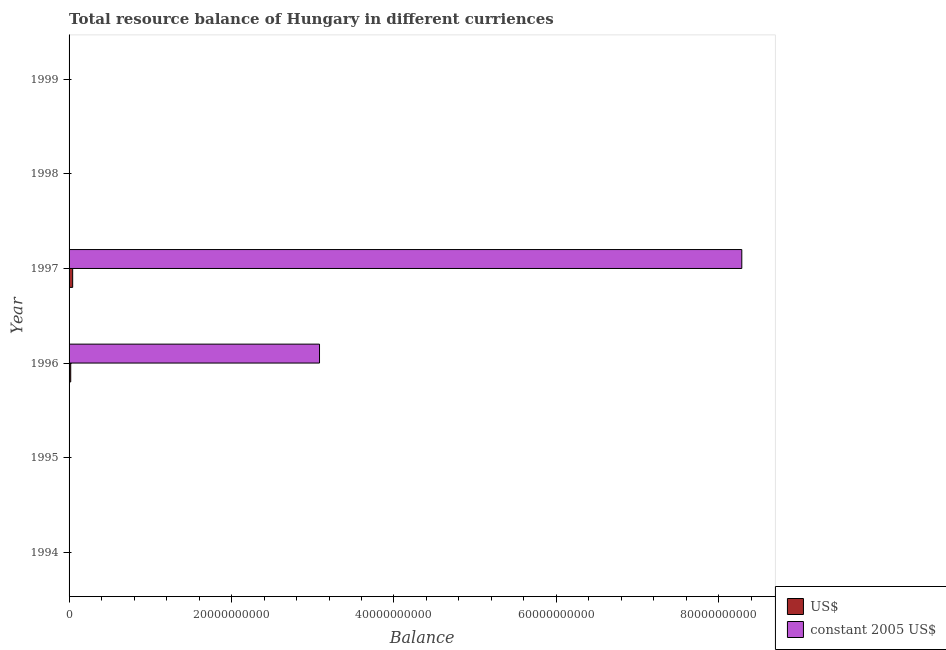How many different coloured bars are there?
Ensure brevity in your answer.  2. Are the number of bars per tick equal to the number of legend labels?
Your answer should be very brief. No. Are the number of bars on each tick of the Y-axis equal?
Make the answer very short. No. How many bars are there on the 5th tick from the top?
Give a very brief answer. 0. What is the label of the 5th group of bars from the top?
Offer a very short reply. 1995. What is the resource balance in constant us$ in 1996?
Keep it short and to the point. 3.08e+1. Across all years, what is the maximum resource balance in us$?
Keep it short and to the point. 4.43e+08. Across all years, what is the minimum resource balance in constant us$?
Offer a terse response. 0. What is the total resource balance in us$ in the graph?
Provide a short and direct response. 6.45e+08. What is the difference between the resource balance in constant us$ in 1996 and that in 1997?
Provide a succinct answer. -5.20e+1. What is the difference between the resource balance in us$ in 1999 and the resource balance in constant us$ in 1996?
Your answer should be very brief. -3.08e+1. What is the average resource balance in constant us$ per year?
Make the answer very short. 1.89e+1. In the year 1996, what is the difference between the resource balance in us$ and resource balance in constant us$?
Offer a very short reply. -3.06e+1. In how many years, is the resource balance in constant us$ greater than 80000000000 units?
Provide a short and direct response. 1. What is the difference between the highest and the lowest resource balance in constant us$?
Your response must be concise. 8.28e+1. In how many years, is the resource balance in us$ greater than the average resource balance in us$ taken over all years?
Keep it short and to the point. 2. Are all the bars in the graph horizontal?
Provide a succinct answer. Yes. Are the values on the major ticks of X-axis written in scientific E-notation?
Ensure brevity in your answer.  No. Does the graph contain any zero values?
Your answer should be very brief. Yes. Does the graph contain grids?
Ensure brevity in your answer.  No. Where does the legend appear in the graph?
Provide a succinct answer. Bottom right. What is the title of the graph?
Keep it short and to the point. Total resource balance of Hungary in different curriences. Does "Crop" appear as one of the legend labels in the graph?
Provide a short and direct response. No. What is the label or title of the X-axis?
Make the answer very short. Balance. What is the label or title of the Y-axis?
Your answer should be very brief. Year. What is the Balance in US$ in 1994?
Give a very brief answer. 0. What is the Balance in constant 2005 US$ in 1995?
Your answer should be very brief. 0. What is the Balance in US$ in 1996?
Provide a short and direct response. 2.02e+08. What is the Balance of constant 2005 US$ in 1996?
Offer a very short reply. 3.08e+1. What is the Balance in US$ in 1997?
Your response must be concise. 4.43e+08. What is the Balance of constant 2005 US$ in 1997?
Your response must be concise. 8.28e+1. What is the Balance in US$ in 1999?
Offer a very short reply. 0. What is the Balance in constant 2005 US$ in 1999?
Your answer should be very brief. 0. Across all years, what is the maximum Balance in US$?
Ensure brevity in your answer.  4.43e+08. Across all years, what is the maximum Balance of constant 2005 US$?
Ensure brevity in your answer.  8.28e+1. Across all years, what is the minimum Balance in constant 2005 US$?
Your answer should be compact. 0. What is the total Balance in US$ in the graph?
Keep it short and to the point. 6.45e+08. What is the total Balance in constant 2005 US$ in the graph?
Give a very brief answer. 1.14e+11. What is the difference between the Balance in US$ in 1996 and that in 1997?
Ensure brevity in your answer.  -2.41e+08. What is the difference between the Balance of constant 2005 US$ in 1996 and that in 1997?
Your answer should be very brief. -5.20e+1. What is the difference between the Balance of US$ in 1996 and the Balance of constant 2005 US$ in 1997?
Your response must be concise. -8.26e+1. What is the average Balance in US$ per year?
Provide a succinct answer. 1.08e+08. What is the average Balance in constant 2005 US$ per year?
Give a very brief answer. 1.89e+1. In the year 1996, what is the difference between the Balance of US$ and Balance of constant 2005 US$?
Keep it short and to the point. -3.06e+1. In the year 1997, what is the difference between the Balance in US$ and Balance in constant 2005 US$?
Offer a very short reply. -8.24e+1. What is the ratio of the Balance of US$ in 1996 to that in 1997?
Make the answer very short. 0.46. What is the ratio of the Balance of constant 2005 US$ in 1996 to that in 1997?
Your answer should be compact. 0.37. What is the difference between the highest and the lowest Balance in US$?
Ensure brevity in your answer.  4.43e+08. What is the difference between the highest and the lowest Balance of constant 2005 US$?
Make the answer very short. 8.28e+1. 